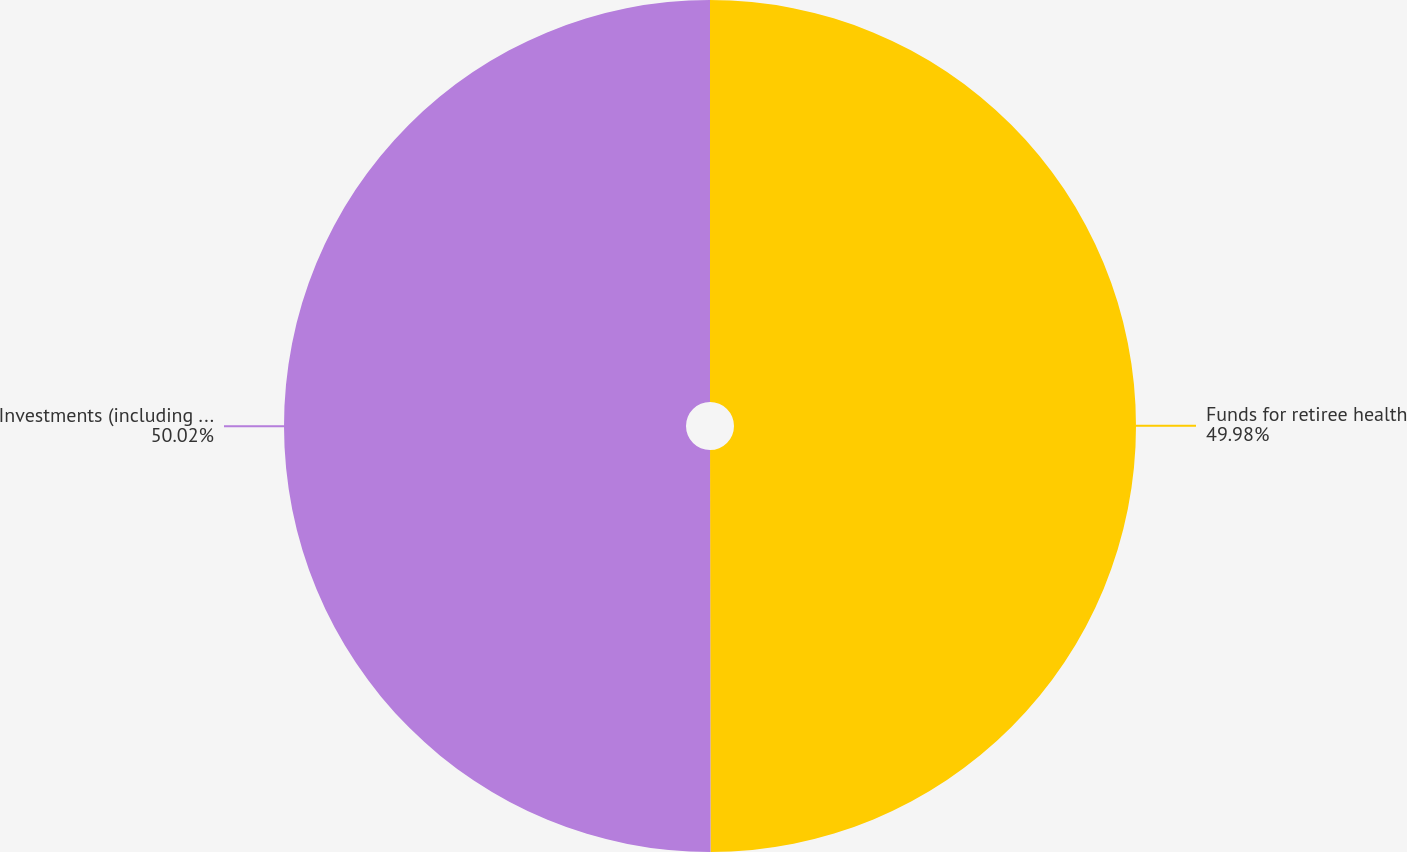Convert chart to OTSL. <chart><loc_0><loc_0><loc_500><loc_500><pie_chart><fcel>Funds for retiree health<fcel>Investments (including funds<nl><fcel>49.98%<fcel>50.02%<nl></chart> 